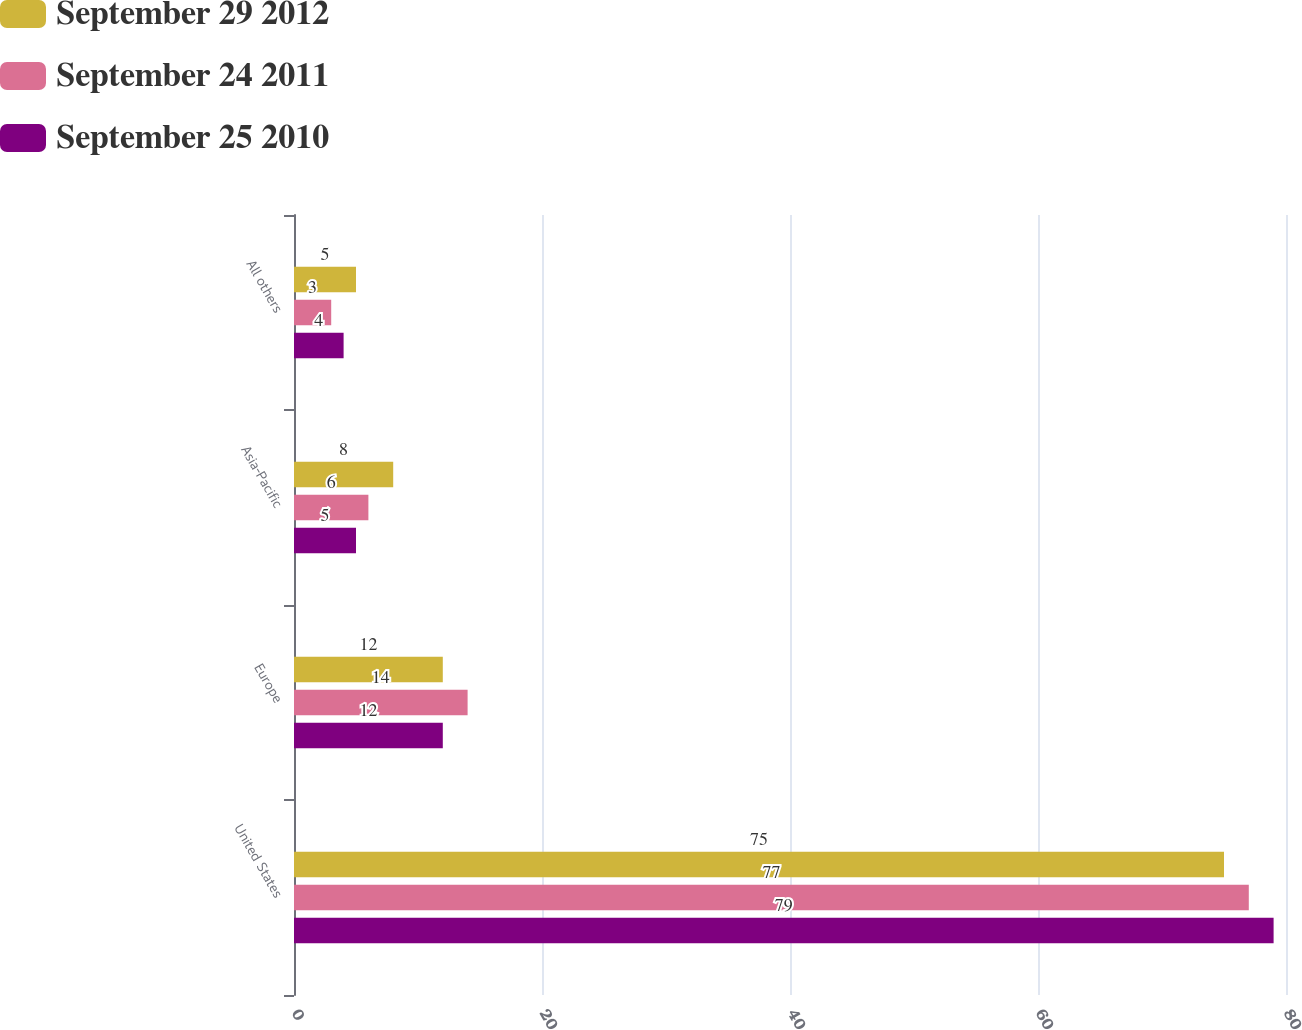<chart> <loc_0><loc_0><loc_500><loc_500><stacked_bar_chart><ecel><fcel>United States<fcel>Europe<fcel>Asia-Pacific<fcel>All others<nl><fcel>September 29 2012<fcel>75<fcel>12<fcel>8<fcel>5<nl><fcel>September 24 2011<fcel>77<fcel>14<fcel>6<fcel>3<nl><fcel>September 25 2010<fcel>79<fcel>12<fcel>5<fcel>4<nl></chart> 